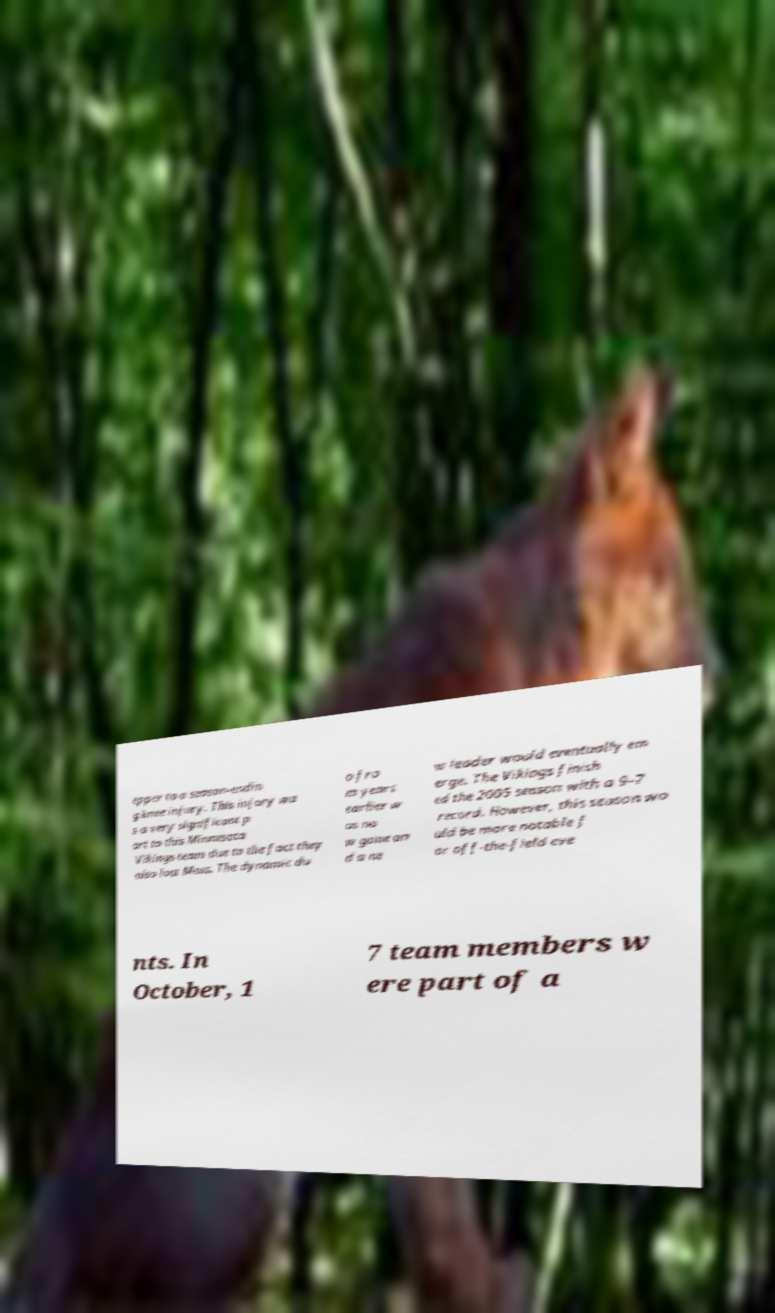Could you assist in decoding the text presented in this image and type it out clearly? epper to a season-endin g knee injury. This injury wa s a very significant p art to this Minnesota Vikings team due to the fact they also lost Moss. The dynamic du o fro m years earlier w as no w gone an d a ne w leader would eventually em erge. The Vikings finish ed the 2005 season with a 9–7 record. However, this season wo uld be more notable f or off-the-field eve nts. In October, 1 7 team members w ere part of a 